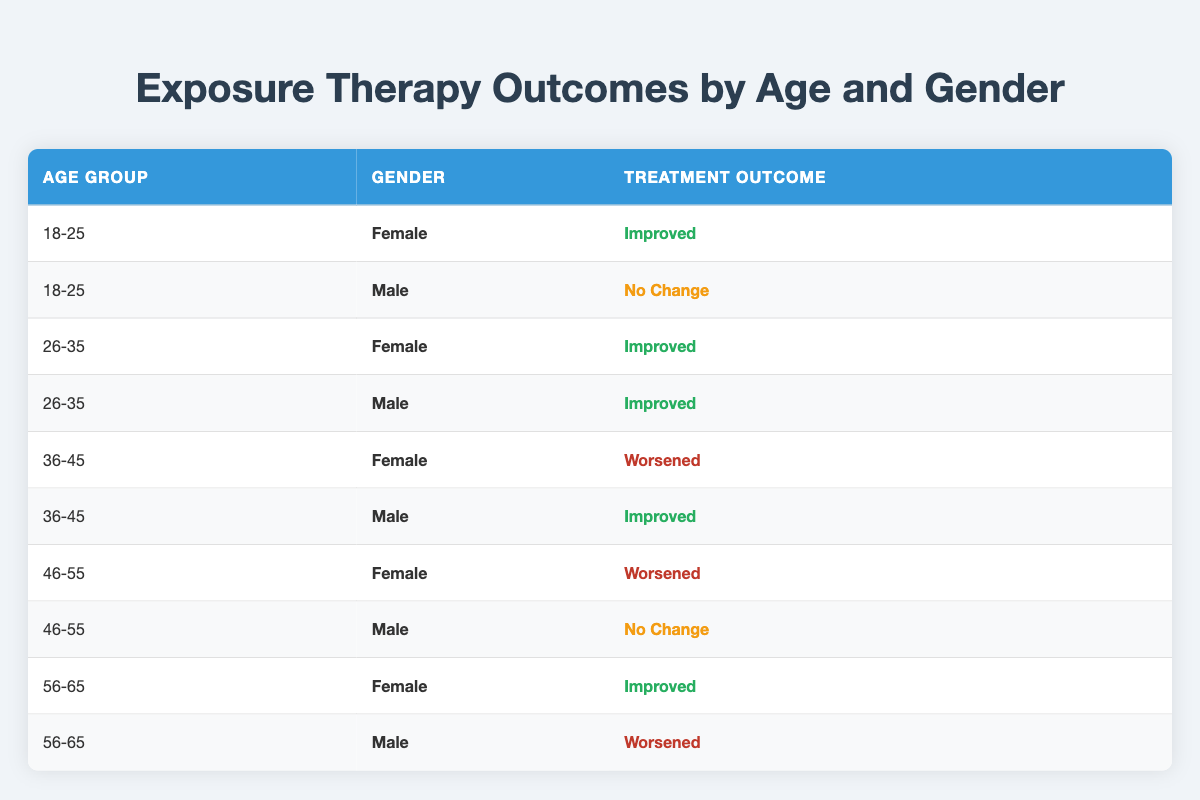What is the treatment outcome for females aged 18-25? In the table, you can find the row corresponding to females in the 18-25 age group, which shows a treatment outcome of "Improved."
Answer: Improved How many males aged 26-35 showed "Improved" outcomes? Looking at the table, there is 1 row for males in the 26-35 age group, and it indicates a treatment outcome of "Improved."
Answer: 1 Are there any patients aged 36-45 who had "No Change" as a treatment outcome? Checking the rows for age group 36-45, there is one male with "Improved" and one female with "Worsened," so there are no patients with "No Change."
Answer: No What percentage of females aged 46-55 experienced a "Worsened" outcome? There are 2 females in the 46-55 age group. One had a "Worsened" outcome, which gives us (1/2) * 100 = 50%.
Answer: 50% Which age group had the highest number of "Improved" outcomes for males? In the table, the age groups are 18-25, 26-35, 36-45, 46-55, and 56-65. The males in 26-35 have 1 "Improved" outcome, males in 36-45 have 1 "Improved," and males in 56-65 have 1 "Worsened." Hence, 26-35 has the highest number of "Improved."
Answer: 26-35 How many total patients showed a "Worsened" outcome across all age groups? Searching through the table, the rows show that 2 females (one in the 36-45 age group and one in the 46-55 age group) and 1 male (in the 56-65 age group) had "Worsened" outcomes, giving us a total of 3.
Answer: 3 Are there more "Improved" outcomes for females than males in the age group of 56-65? In the 56-65 age group, the female has an "Improved" outcome, while the male has a "Worsened" outcome. Thus, yes, there is more "Improved" outcome for females.
Answer: Yes What is the overall treatment outcome for patients aged 36-45? In the 36-45 age group, there is one female with "Worsened" and one male with "Improved," resulting in mixed outcomes where the overall is not a singular outcome, but we note both outcomes exist.
Answer: Mixed outcomes 